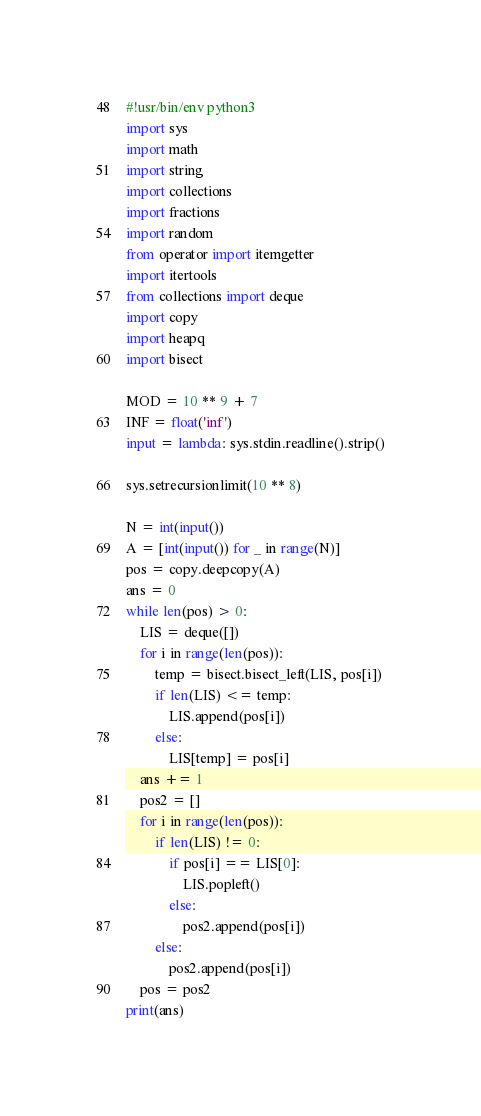Convert code to text. <code><loc_0><loc_0><loc_500><loc_500><_Python_>#!usr/bin/env python3
import sys
import math
import string
import collections
import fractions
import random
from operator import itemgetter
import itertools
from collections import deque
import copy
import heapq
import bisect

MOD = 10 ** 9 + 7
INF = float('inf')
input = lambda: sys.stdin.readline().strip()

sys.setrecursionlimit(10 ** 8)

N = int(input())
A = [int(input()) for _ in range(N)]
pos = copy.deepcopy(A)
ans = 0
while len(pos) > 0:
    LIS = deque([])
    for i in range(len(pos)):
        temp = bisect.bisect_left(LIS, pos[i])
        if len(LIS) <= temp:
            LIS.append(pos[i])
        else:
            LIS[temp] = pos[i]
    ans += 1
    pos2 = []
    for i in range(len(pos)):
        if len(LIS) != 0:
            if pos[i] == LIS[0]:
                LIS.popleft()
            else:
                pos2.append(pos[i])
        else:
            pos2.append(pos[i])
    pos = pos2
print(ans)</code> 